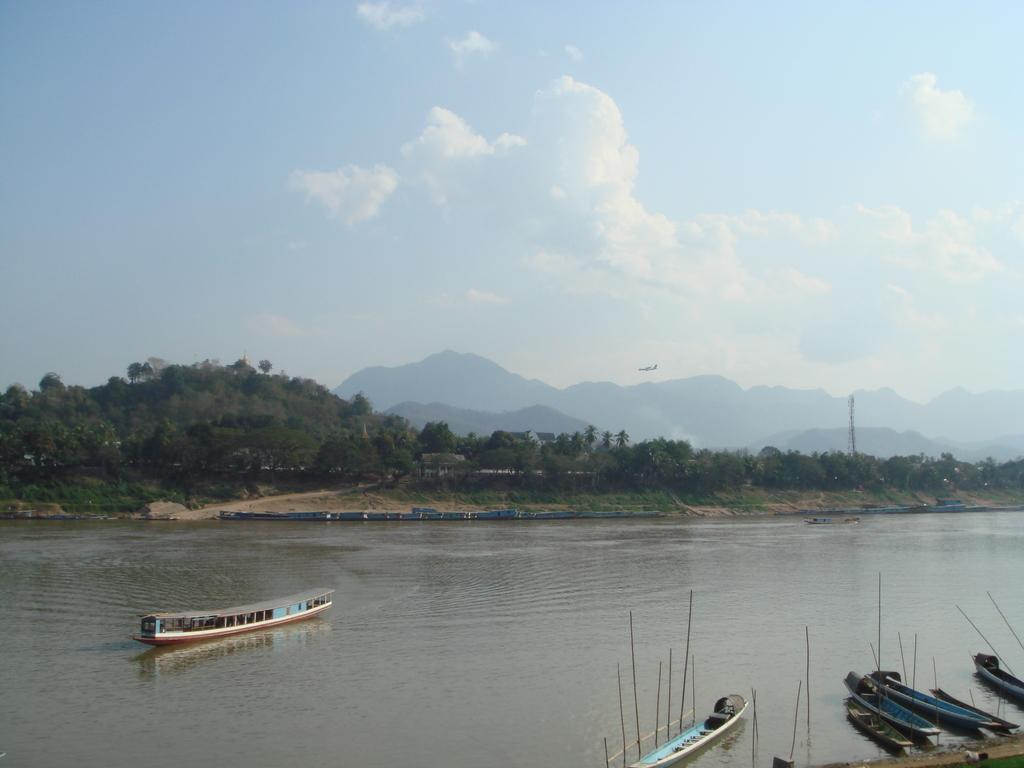What body of water is present in the image? There is a river in the image. What is on the river in the image? There are boats on the river. What type of natural environment can be seen in the background of the image? There are trees and mountains in the background of the image. What is the condition of the sky in the background of the image? The sky is cloudy in the background of the image. How many buttons can be seen on the boats in the image? There are no buttons visible on the boats in the image. What type of pleasure can be experienced by the people on the boats in the image? The image does not show people on the boats, so it is impossible to determine what type of pleasure they might be experiencing. 